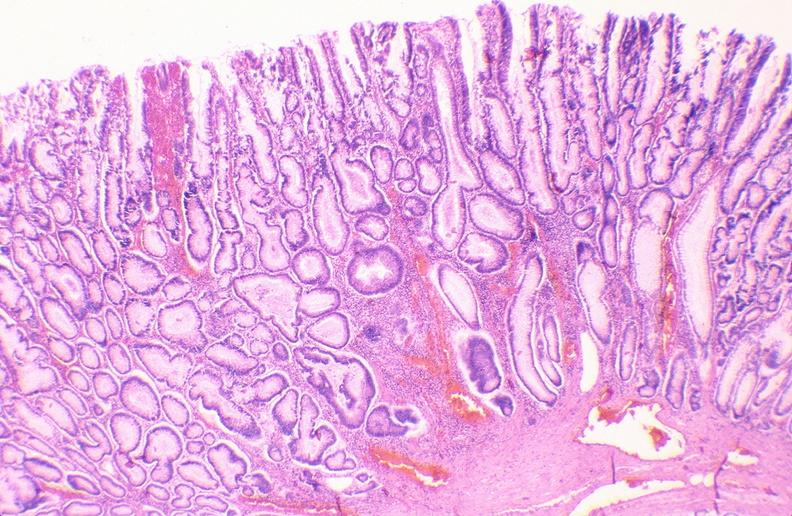does muscle atrophy show colon, adenomatous polyp?
Answer the question using a single word or phrase. No 